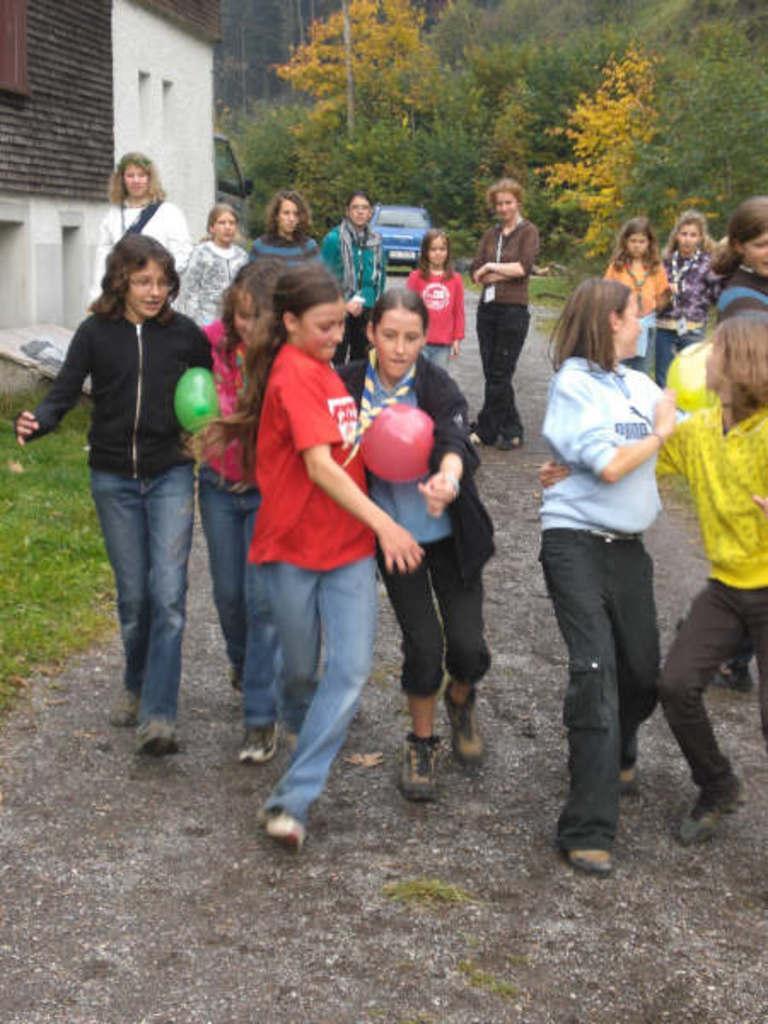Please provide a concise description of this image. In this image, we can see the girls are playing a game with balloons on the walkway. In the background, we can see people, house, grass, plants, vehicle and trees. 